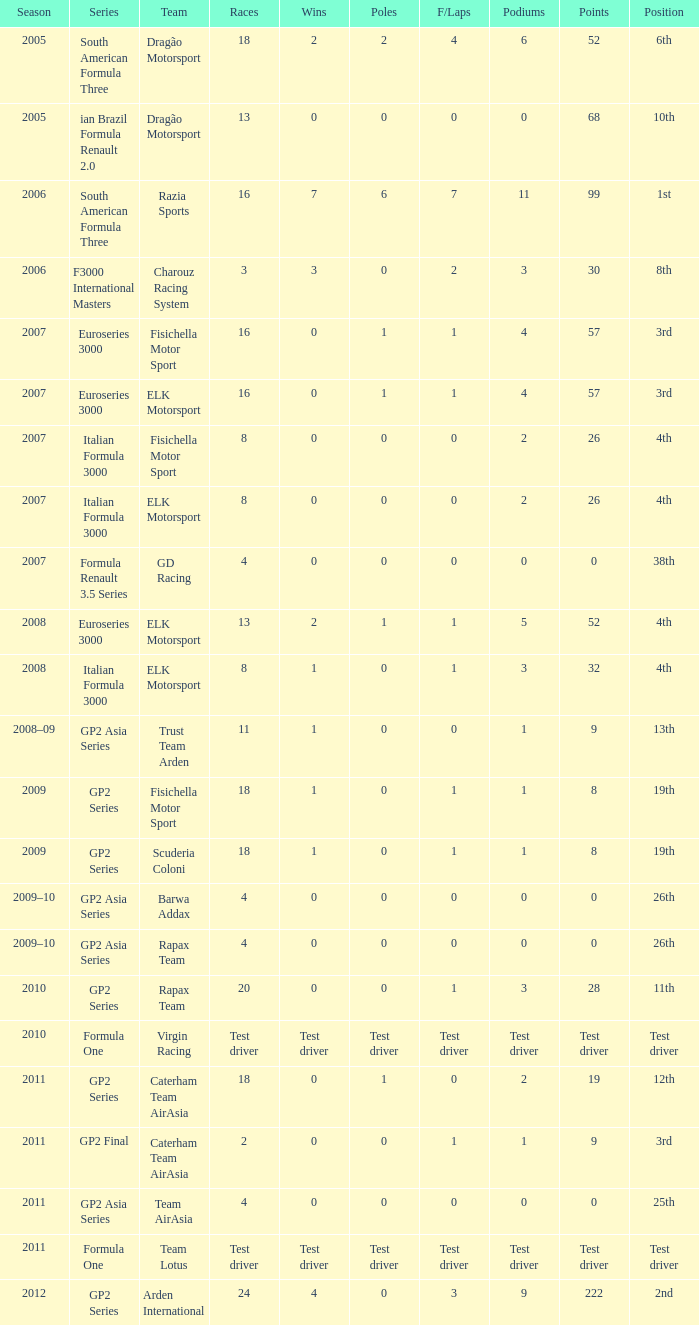What were the occasions in the year when his podiums totaled 5? 52.0. 